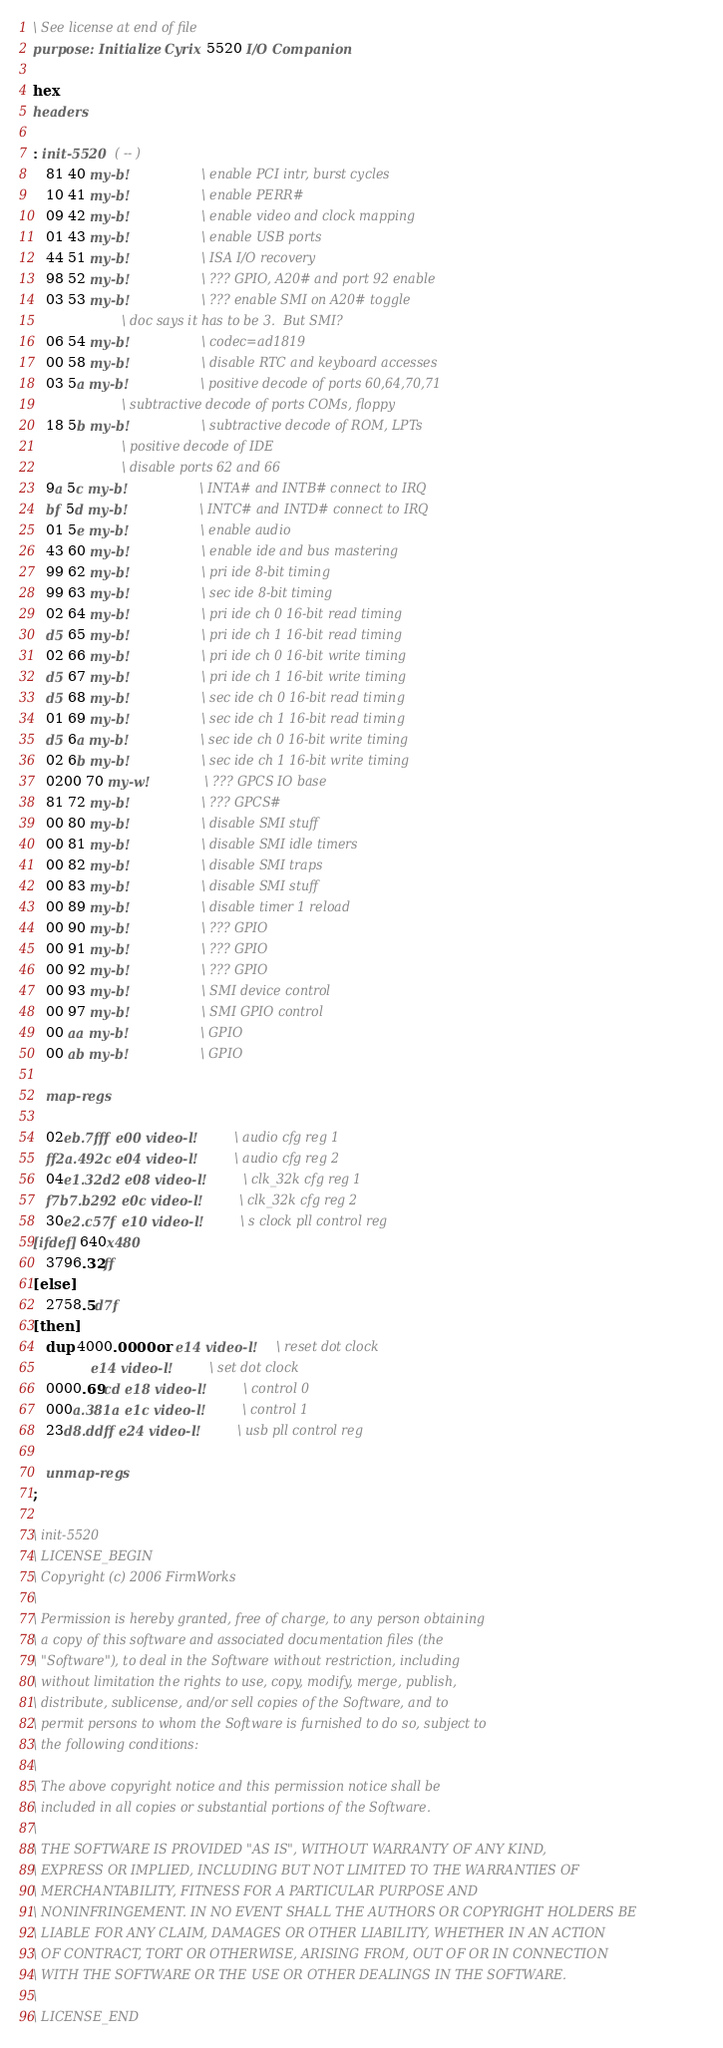Convert code to text. <code><loc_0><loc_0><loc_500><loc_500><_Forth_>\ See license at end of file
purpose: Initialize Cyrix 5520 I/O Companion

hex
headers

: init-5520  ( -- )
   81 40 my-b!				\ enable PCI intr, burst cycles
   10 41 my-b!				\ enable PERR#
   09 42 my-b!				\ enable video and clock mapping
   01 43 my-b!				\ enable USB ports
   44 51 my-b!				\ ISA I/O recovery
   98 52 my-b!				\ ??? GPIO, A20# and port 92 enable
   03 53 my-b!				\ ??? enable SMI on A20# toggle
					\ doc says it has to be 3.  But SMI?
   06 54 my-b!				\ codec=ad1819
   00 58 my-b!				\ disable RTC and keyboard accesses
   03 5a my-b!				\ positive decode of ports 60,64,70,71
					\ subtractive decode of ports COMs, floppy
   18 5b my-b!				\ subtractive decode of ROM, LPTs
					\ positive decode of IDE
					\ disable ports 62 and 66
   9a 5c my-b!				\ INTA# and INTB# connect to IRQ
   bf 5d my-b!				\ INTC# and INTD# connect to IRQ
   01 5e my-b!				\ enable audio
   43 60 my-b!				\ enable ide and bus mastering
   99 62 my-b!				\ pri ide 8-bit timing
   99 63 my-b!				\ sec ide 8-bit timing
   02 64 my-b!				\ pri ide ch 0 16-bit read timing
   d5 65 my-b!				\ pri ide ch 1 16-bit read timing
   02 66 my-b!				\ pri ide ch 0 16-bit write timing
   d5 67 my-b!				\ pri ide ch 1 16-bit write timing
   d5 68 my-b!				\ sec ide ch 0 16-bit read timing
   01 69 my-b!				\ sec ide ch 1 16-bit read timing
   d5 6a my-b!				\ sec ide ch 0 16-bit write timing
   02 6b my-b!				\ sec ide ch 1 16-bit write timing
   0200 70 my-w!			\ ??? GPCS IO base
   81 72 my-b!				\ ??? GPCS#
   00 80 my-b!				\ disable SMI stuff
   00 81 my-b!				\ disable SMI idle timers
   00 82 my-b!				\ disable SMI traps
   00 83 my-b!				\ disable SMI stuff
   00 89 my-b!				\ disable timer 1 reload
   00 90 my-b!				\ ??? GPIO
   00 91 my-b!				\ ??? GPIO
   00 92 my-b!				\ ??? GPIO
   00 93 my-b!				\ SMI device control
   00 97 my-b!				\ SMI GPIO control
   00 aa my-b!				\ GPIO
   00 ab my-b!				\ GPIO

   map-regs

   02eb.7fff e00 video-l!		\ audio cfg reg 1
   ff2a.492c e04 video-l!		\ audio cfg reg 2
   04e1.32d2 e08 video-l!		\ clk_32k cfg reg 1
   f7b7.b292 e0c video-l!		\ clk_32k cfg reg 2
   30e2.c57f e10 video-l!		\ s clock pll control reg
[ifdef] 640x480
   3796.32ff
[else]
   2758.5d7f
[then]
   dup 4000.0000 or e14 video-l!	\ reset dot clock
             e14 video-l!		\ set dot clock
   0000.69cd e18 video-l!		\ control 0
   000a.381a e1c video-l!		\ control 1
   23d8.ddff e24 video-l!		\ usb pll control reg

   unmap-regs
;

\ init-5520
\ LICENSE_BEGIN
\ Copyright (c) 2006 FirmWorks
\ 
\ Permission is hereby granted, free of charge, to any person obtaining
\ a copy of this software and associated documentation files (the
\ "Software"), to deal in the Software without restriction, including
\ without limitation the rights to use, copy, modify, merge, publish,
\ distribute, sublicense, and/or sell copies of the Software, and to
\ permit persons to whom the Software is furnished to do so, subject to
\ the following conditions:
\ 
\ The above copyright notice and this permission notice shall be
\ included in all copies or substantial portions of the Software.
\ 
\ THE SOFTWARE IS PROVIDED "AS IS", WITHOUT WARRANTY OF ANY KIND,
\ EXPRESS OR IMPLIED, INCLUDING BUT NOT LIMITED TO THE WARRANTIES OF
\ MERCHANTABILITY, FITNESS FOR A PARTICULAR PURPOSE AND
\ NONINFRINGEMENT. IN NO EVENT SHALL THE AUTHORS OR COPYRIGHT HOLDERS BE
\ LIABLE FOR ANY CLAIM, DAMAGES OR OTHER LIABILITY, WHETHER IN AN ACTION
\ OF CONTRACT, TORT OR OTHERWISE, ARISING FROM, OUT OF OR IN CONNECTION
\ WITH THE SOFTWARE OR THE USE OR OTHER DEALINGS IN THE SOFTWARE.
\
\ LICENSE_END
</code> 